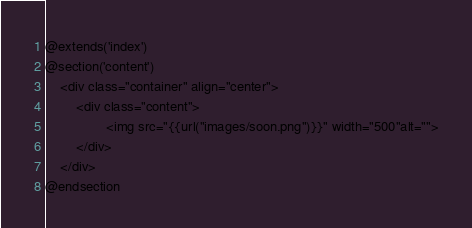Convert code to text. <code><loc_0><loc_0><loc_500><loc_500><_PHP_>




@extends('index')
@section('content')
    <div class="container" align="center">
        <div class="content">
                <img src="{{url("images/soon.png")}}" width="500"alt="">
        </div>
    </div>
@endsection
</code> 